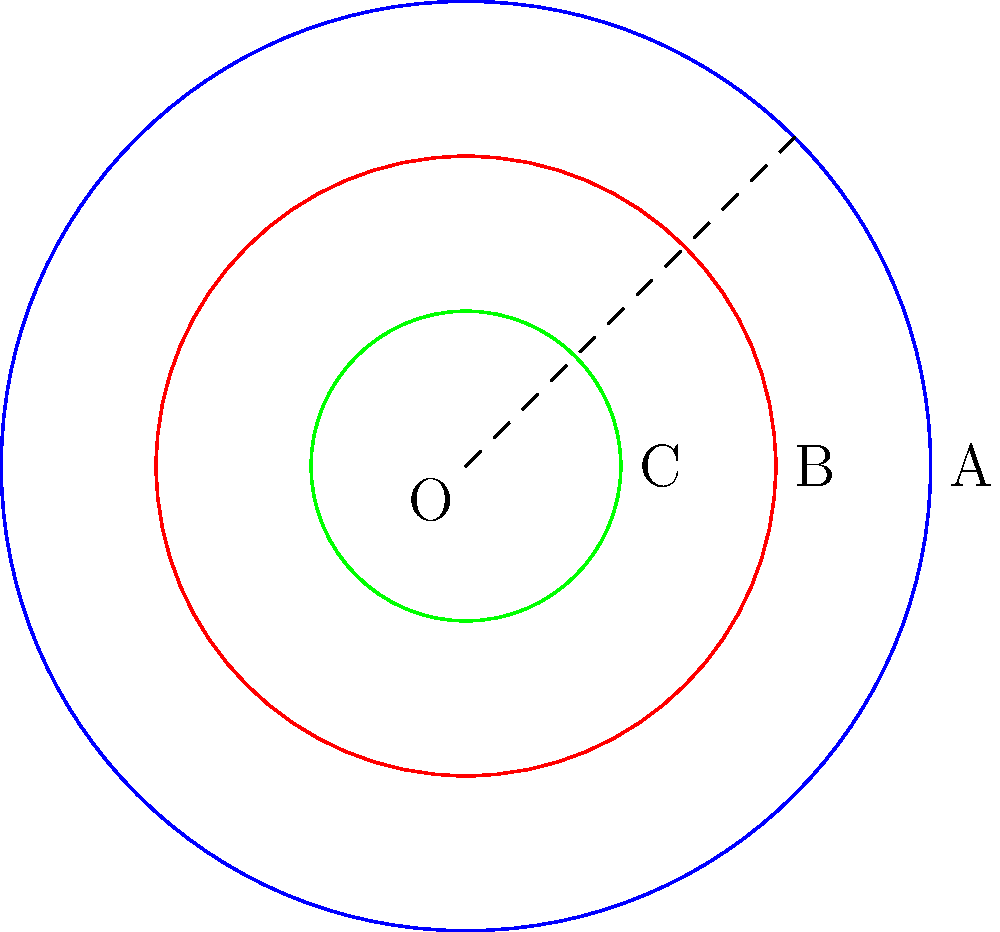In a circular mandala design inspired by Buddhist art from Central Asia, three concentric circles are drawn with radii in arithmetic progression. If the area between the outermost and middle circles is 5π square units, what is the area of the innermost circle? Let's approach this step-by-step:

1) Let the radii of the three circles be $r$, $r-d$, and $r-2d$, where $d$ is the common difference in the arithmetic progression.

2) The area between the outermost and middle circles is given:
   $$ \pi r^2 - \pi(r-d)^2 = 5\pi $$

3) Expanding this equation:
   $$ \pi r^2 - \pi(r^2-2rd+d^2) = 5\pi $$
   $$ \pi(2rd-d^2) = 5\pi $$
   $$ 2rd-d^2 = 5 $$

4) We need another equation. The area between the middle and innermost circles is:
   $$ \pi(r-d)^2 - \pi(r-2d)^2 = \pi(2rd-3d^2) $$

5) Due to the arithmetic progression, this area must equal $5\pi$ as well:
   $$ 2rd-3d^2 = 5 $$

6) Subtracting equation in step 3 from this:
   $$ -2d^2 = 0 $$
   $$ d^2 = 0 $$
   $$ d = 0 $$

7) Substituting back into the equation from step 3:
   $$ 2r(0) - 0^2 = 5 $$
   $$ 0 = 5 $$

   This is impossible, so our initial assumption that the radii form an arithmetic progression must be incorrect.

8) Let's try geometric progression instead. Let the radii be $r$, $rk$, and $rk^2$, where $k$ is the common ratio.

9) The area between the outermost and middle circles:
   $$ \pi r^2 - \pi(rk)^2 = 5\pi $$
   $$ r^2(1-k^2) = 5 $$

10) The area between the middle and innermost circles:
    $$ \pi(rk)^2 - \pi(rk^2)^2 = 5\pi $$
    $$ r^2k^2(1-k^2) = 5 $$

11) Dividing these equations:
    $$ k^2 = \frac{1}{2} $$
    $$ k = \frac{1}{\sqrt{2}} $$

12) Substituting back into the equation from step 9:
    $$ r^2(1-\frac{1}{2}) = 5 $$
    $$ r^2 = 10 $$
    $$ r = \sqrt{10} $$

13) The radius of the innermost circle is $rk^2 = \sqrt{10} \cdot (\frac{1}{\sqrt{2}})^2 = \frac{\sqrt{10}}{2}$

14) Therefore, the area of the innermost circle is:
    $$ \pi (\frac{\sqrt{10}}{2})^2 = \frac{5\pi}{2} $$
Answer: $\frac{5\pi}{2}$ square units 